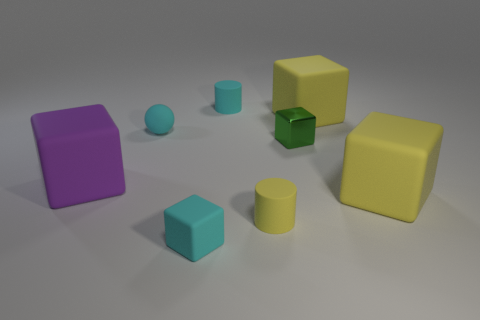Add 1 large brown shiny cylinders. How many objects exist? 9 Subtract all large purple rubber cubes. How many cubes are left? 4 Subtract all large brown matte cubes. Subtract all blocks. How many objects are left? 3 Add 7 yellow cylinders. How many yellow cylinders are left? 8 Add 6 purple spheres. How many purple spheres exist? 6 Subtract all green blocks. How many blocks are left? 4 Subtract 1 purple blocks. How many objects are left? 7 Subtract all balls. How many objects are left? 7 Subtract 1 cylinders. How many cylinders are left? 1 Subtract all gray cylinders. Subtract all purple cubes. How many cylinders are left? 2 